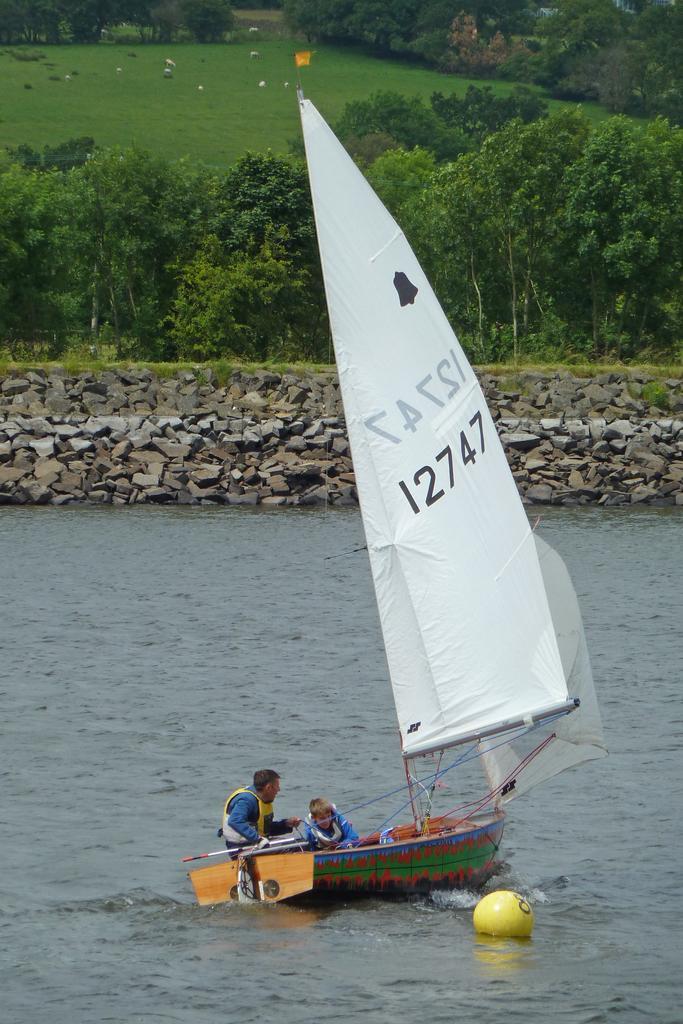Please provide a concise description of this image. In this image we can see the boat on the water and there are two persons sitting on the boat and holding stick. And there is the balloon on the water. And at the back there are stones, grass, flag, and trees. 